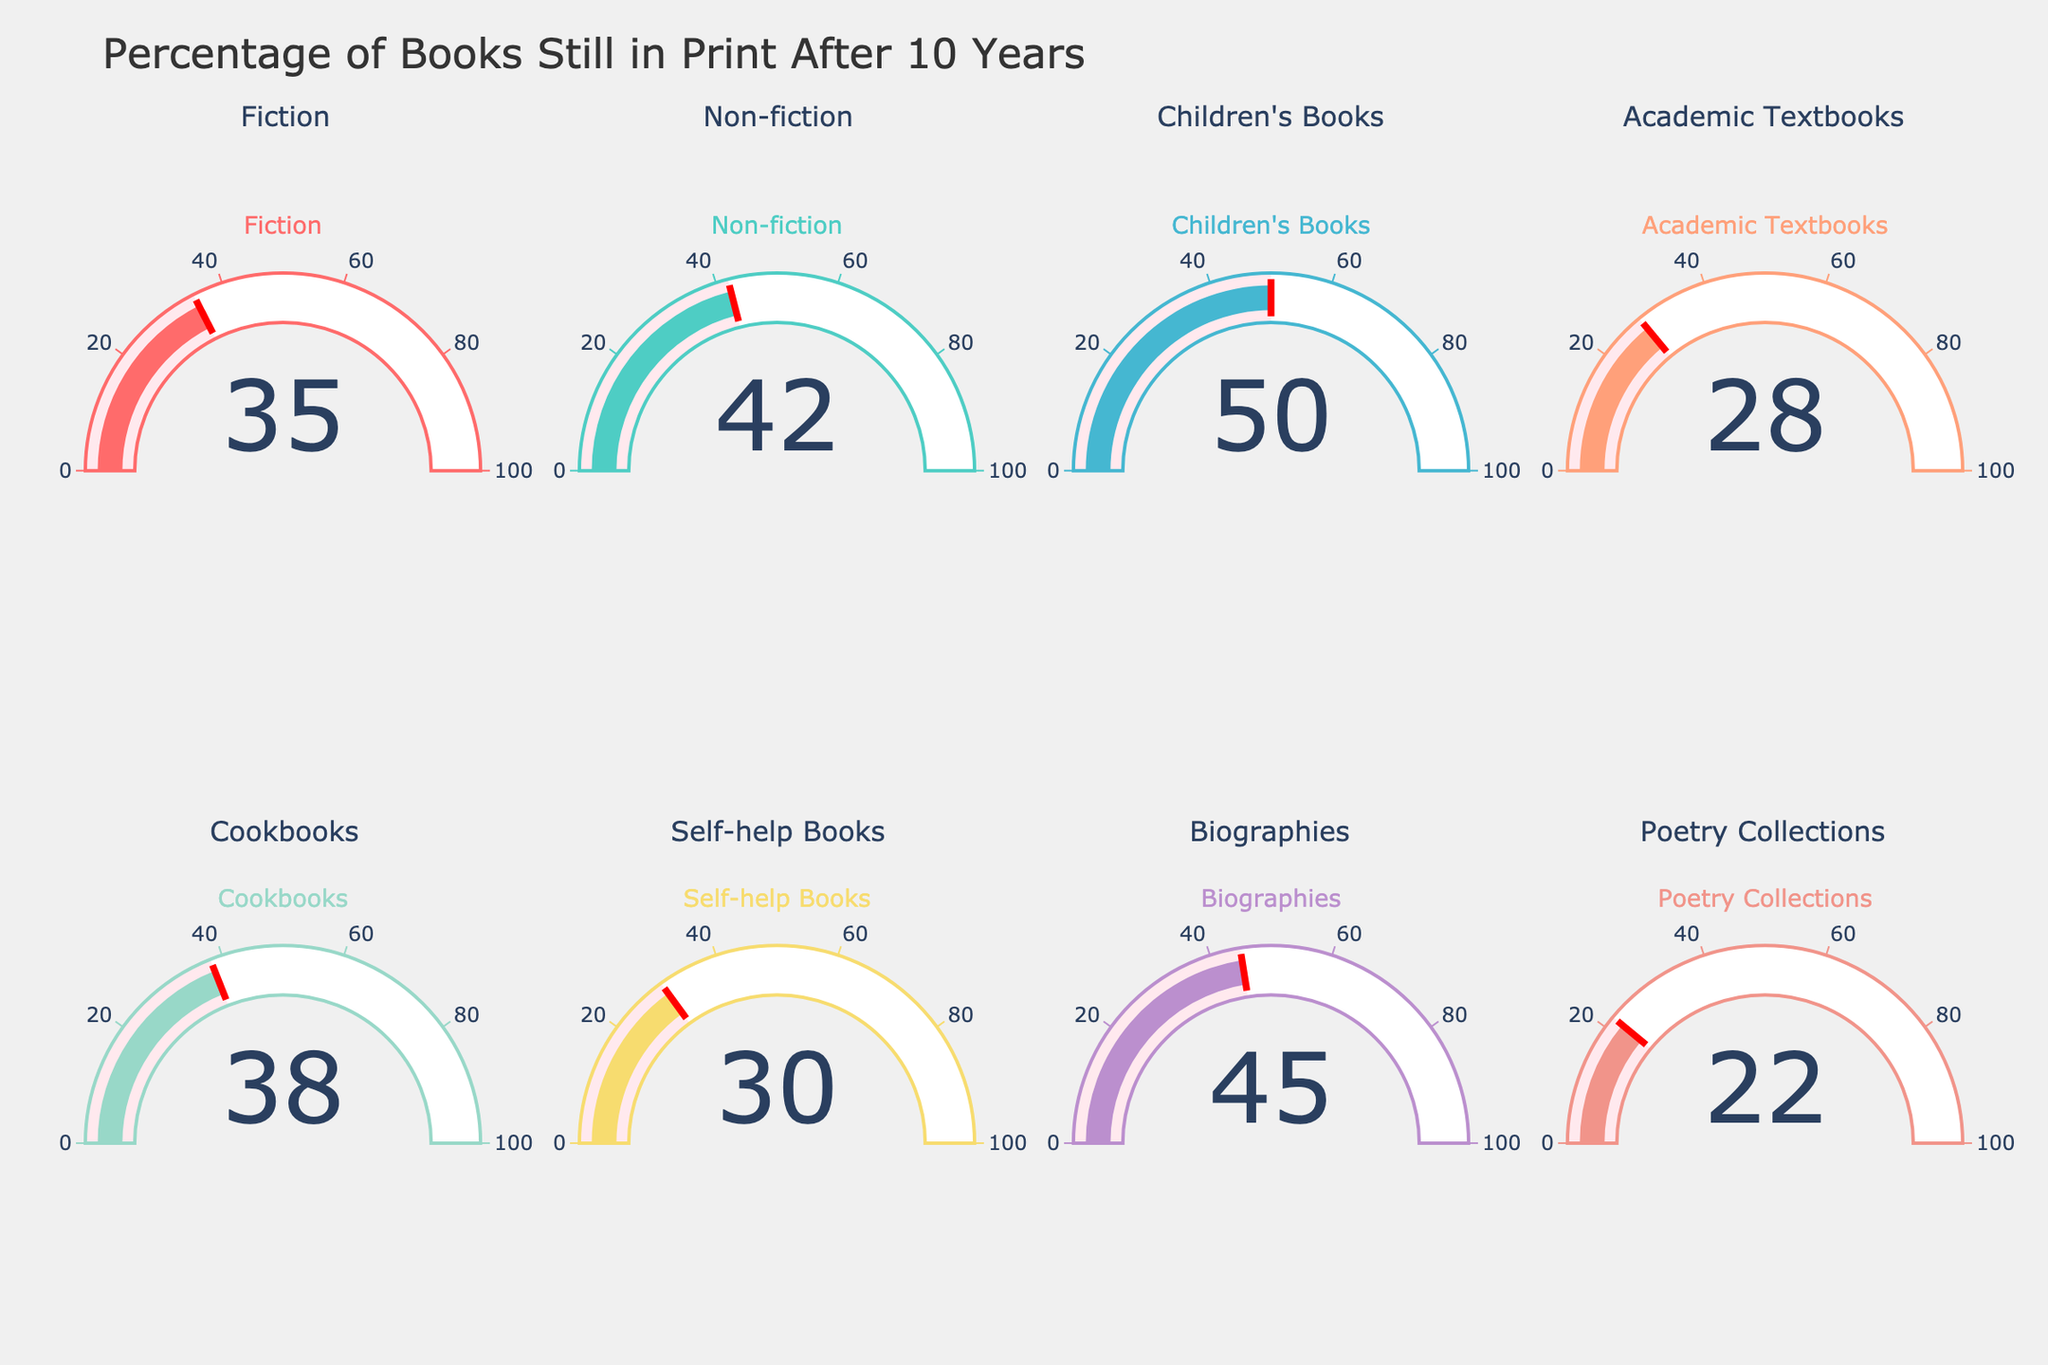what is the title of the figure? The title of the figure can be found at the top of the plot and it is essential for summarizing the content of the plot. The stated title helps immediately understand what kind of data visualization is presented.
Answer: Percentage of Books Still in Print After 10 Years How many categories are displayed in the figure? To determine the number of categories, count the gauges in the figure since each gauge represents a category. Note that the gauges are organized in rows and columns.
Answer: 8 Which category has the highest percentage of books still in print after 10 years? Locate the gauge with the highest value displayed among all categories. This can be quickly recognized as the gauge with the highest number.
Answer: Children's Books Which category has the lowest percentage of books still in print after 10 years? Locate the gauge with the lowest value. This can be identified as the gauge with the smallest number.
Answer: Poetry Collections What's the difference in percentage between Biographies and Self-help Books? Identify the values for Biographies and Self-help Books. Biographies is 45%, and Self-help Books is 30%. Calculate the difference: 45% - 30% = 15%.
Answer: 15% Compare the percentage of books still in print for Fiction and Cookbooks. Which is higher and by how much? Identify the values for Fiction (35%) and Cookbooks (38%). Cookbooks has a higher value. Calculate the difference: 38% - 35% = 3%.
Answer: Cookbooks by 3% What is the average percentage of books still in print across all categories? Find the values for all categories: Fiction (35%), Non-fiction (42%), Children's Books (50%), Academic Textbooks (28%), Cookbooks (38%), Self-help Books (30%), Biographies (45%), Poetry Collections (22%). Sum these values: 35 + 42 + 50 + 28 + 38 + 30 + 45 + 22 = 290. Then divide by the number of categories (8): 290 / 8 = 36.25%.
Answer: 36.25% Which categories have a percentage between 30% and 40%? Identify the values within the specified range: Fiction (35%), Cookbooks (38%), Self-help Books (30%). These categories fall within the range from 30% to 40%.
Answer: Fiction, Cookbooks, Self-help Books 